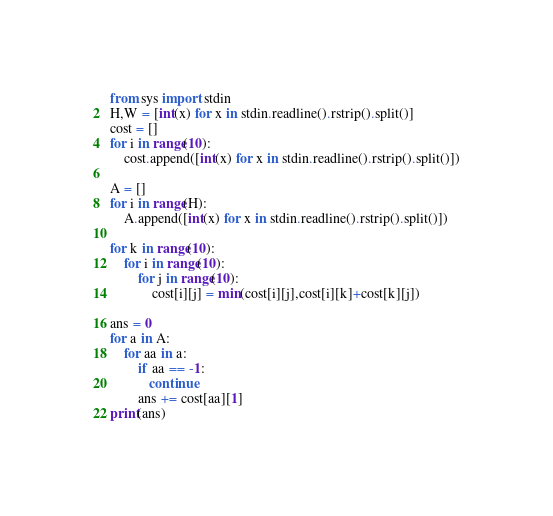<code> <loc_0><loc_0><loc_500><loc_500><_Python_>from sys import stdin
H,W = [int(x) for x in stdin.readline().rstrip().split()]
cost = []
for i in range(10):
    cost.append([int(x) for x in stdin.readline().rstrip().split()])

A = []
for i in range(H):
    A.append([int(x) for x in stdin.readline().rstrip().split()])

for k in range(10):
    for i in range(10):
        for j in range(10):
            cost[i][j] = min(cost[i][j],cost[i][k]+cost[k][j])

ans = 0
for a in A:
    for aa in a:
        if aa == -1:
           continue
        ans += cost[aa][1]
print(ans)</code> 